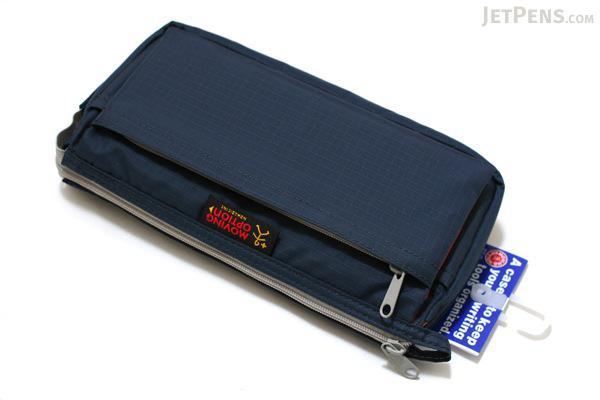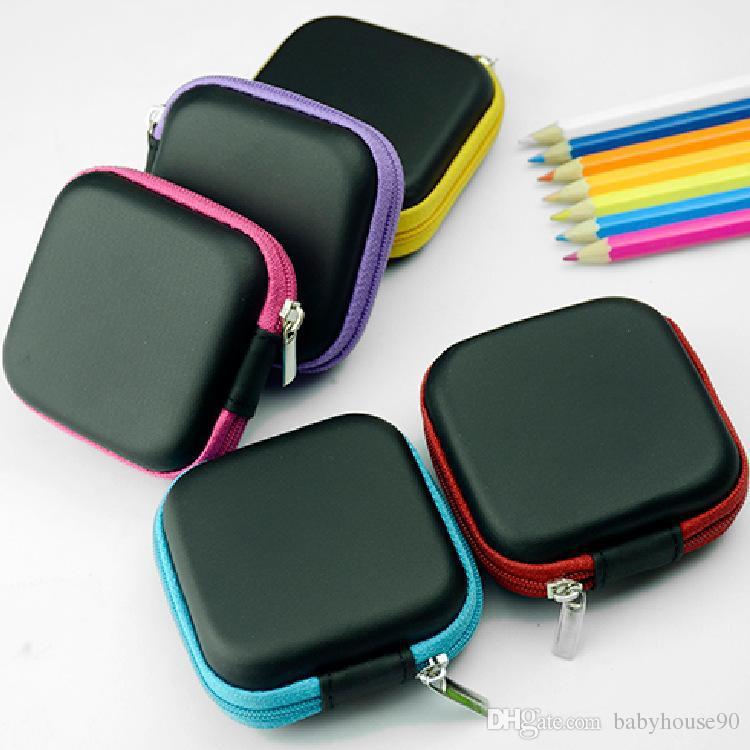The first image is the image on the left, the second image is the image on the right. Examine the images to the left and right. Is the description "At least one image contains a single pencil case." accurate? Answer yes or no. Yes. The first image is the image on the left, the second image is the image on the right. Considering the images on both sides, is "There is an image that has an open and a closed case" valid? Answer yes or no. No. 